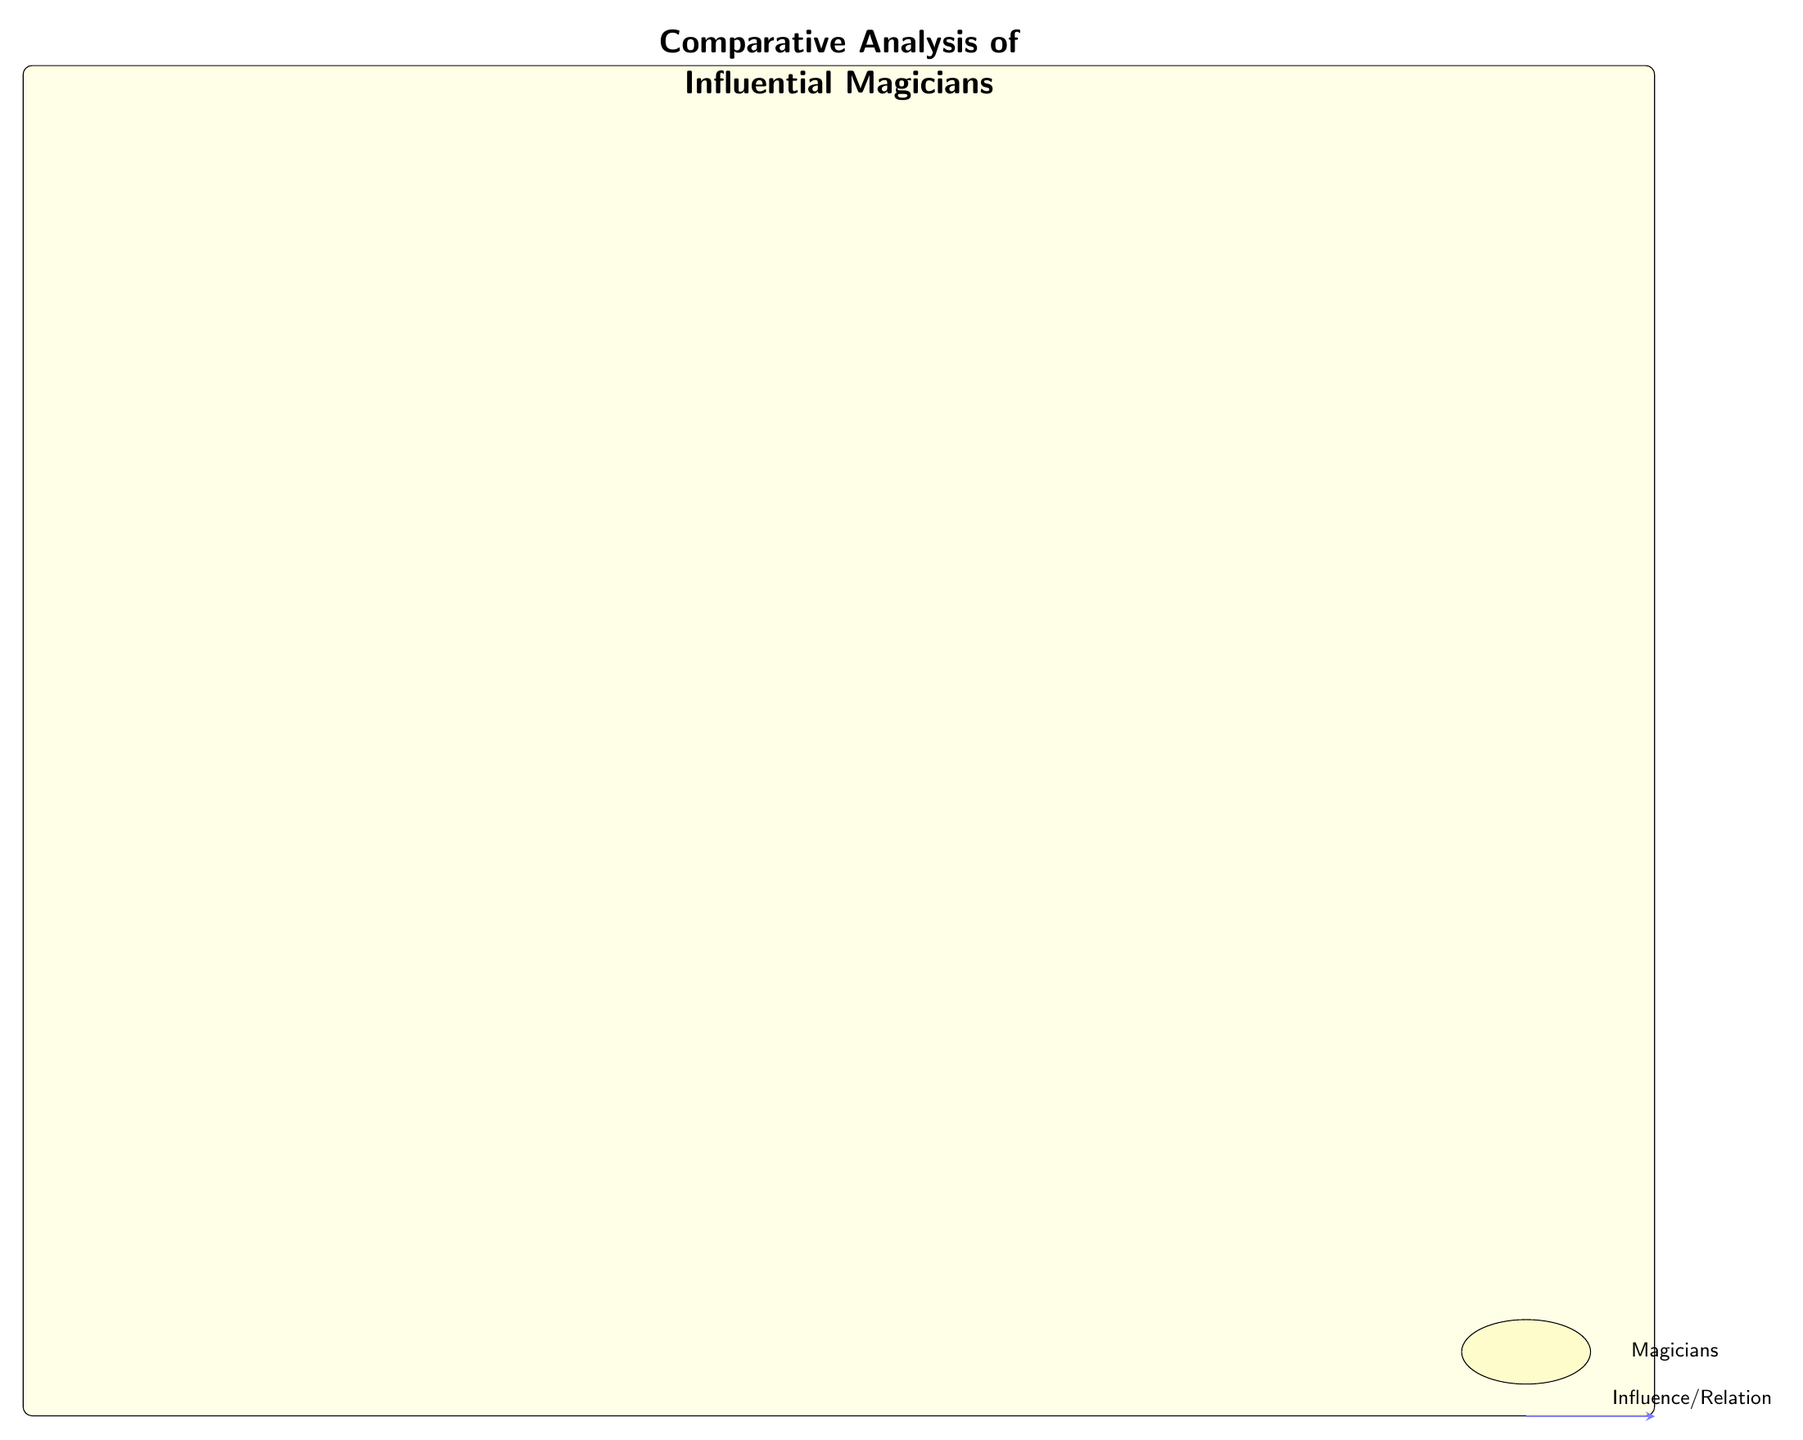What is the signature trick of David Copperfield? The diagram indicates that David Copperfield's signature trick is the "Statue of Liberty Disappearance." This information is found directly in the node representing Copperfield, which mentions this trick prominently.
Answer: Statue of Liberty Disappearance How many magicians are represented in the diagram? Counting the nodes represented in the diagram, there are a total of six magicians presented: Harry Houdini, David Copperfield, David Blaine, Criss Angel, Lance Burton, and Penn & Teller. This can be directly counted by looking at the number of magician nodes in the diagram.
Answer: 6 Which magician is noted for the Bullet Catch trick? The diagram explicitly states that the trick "Bullet Catch" is associated with the comedy magic duo Penn & Teller. This is directly stated in their node, making it easy to identify.
Answer: Penn & Teller What connection is noted between Harry Houdini and David Copperfield? The diagram shows a directional relationship labeled "Innovations in Illusions" going from Harry Houdini to David Copperfield. This indicates that Houdini's contributions influenced Copperfield's work.
Answer: Innovations in Illusions Which magician has their influence described as "Street Magic Influence"? The arrow in the diagram indicates that David Blaine's influence is described with the phrase "Street Magic Influence", showing a flow from Blaine to Criss Angel. This phrasing is associated directly with Blaine's node.
Answer: David Blaine 